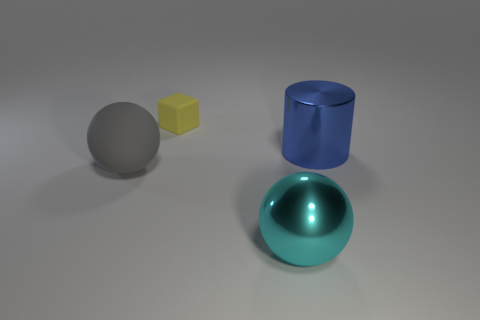Add 4 tiny brown matte objects. How many objects exist? 8 Subtract 1 cylinders. How many cylinders are left? 0 Subtract all cylinders. How many objects are left? 3 Add 1 small objects. How many small objects are left? 2 Add 1 big green shiny spheres. How many big green shiny spheres exist? 1 Subtract 0 red cylinders. How many objects are left? 4 Subtract all green balls. Subtract all yellow cylinders. How many balls are left? 2 Subtract all large red matte balls. Subtract all metallic cylinders. How many objects are left? 3 